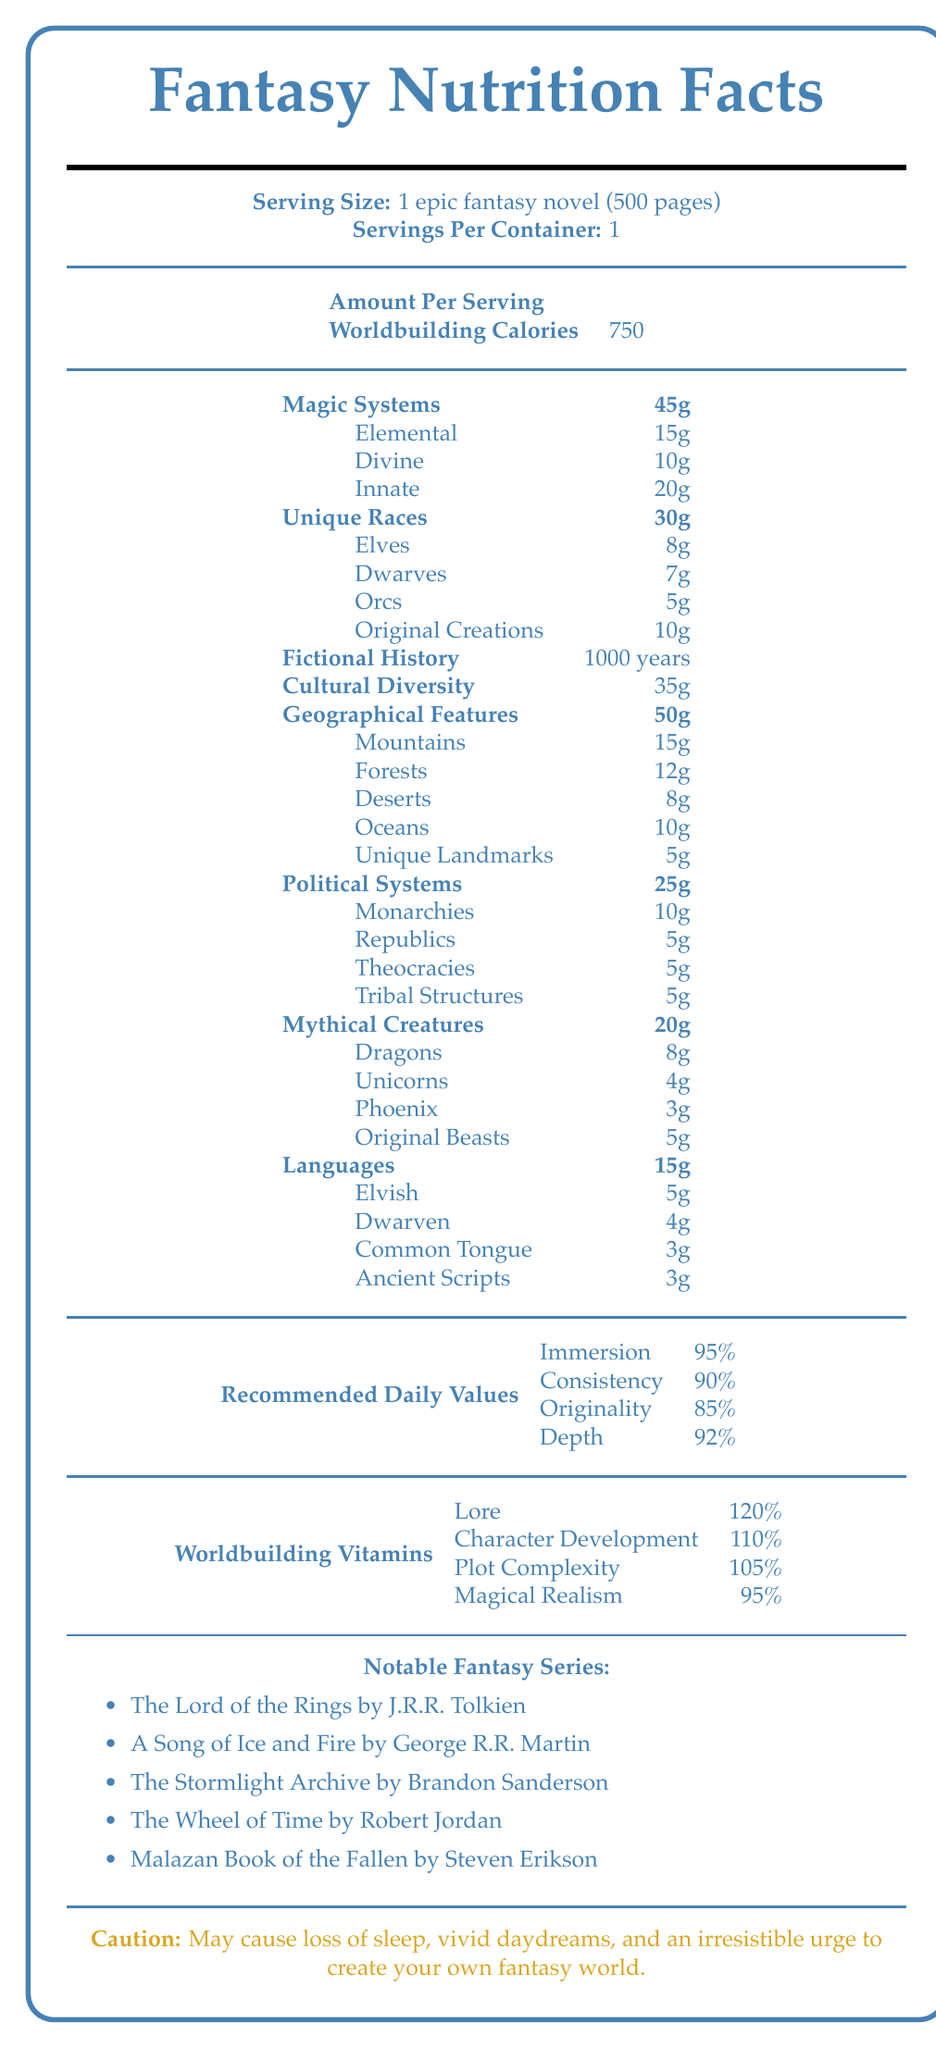1. What is the serving size for this document? The document states that the serving size is 1 epic fantasy novel consisting of 500 pages.
Answer: 1 epic fantasy novel (500 pages) 2. How many calories does the worldbuilding contain per serving? It's listed in the "Amount Per Serving" section as 750 Worldbuilding Calories.
Answer: 750 3. What is the total amount of magic systems in grams per serving? The "Magic Systems" section shows the total as 45g.
Answer: 45g 4. How many grams of Elvish language are there per serving? The "Languages" section indicates that Elvish has 5g per serving.
Answer: 5g 5. Name one fantasy series mentioned in the notable fantasy series list. The list includes "The Lord of the Rings by J.R.R. Tolkien" as one of the notable fantasy series.
Answer: The Lord of the Rings by J.R.R. Tolkien 6. Which type of mythical creature has the highest amount per serving?
   A. Dragons
   B. Unicorns
   C. Phoenix
   D. Original Beasts The "Mythical Creatures" section lists Dragons with the highest amount at 8g.
Answer: A. Dragons 7. What is the percentage of Character Development in Worldbuilding Vitamins?
   I. 95%
   II. 105%
   III. 110%
   IV. 120% The "Worldbuilding Vitamins" section shows Character Development at 110%.
Answer: III. 110% 8. The sum of the grams of Orcs and Elves exceeds the amount of Original Creations. Orcs are 5g and Elves are 8g, totaling 13g. Original Creations are listed as 10g, so the sum (13g) does not exceed 10g.
Answer: No 9. Summarize the main idea of the document. The document is formatted like a nutrition label and breaks down the elements and complexities involved in worldbuilding for an epic fantasy novel. It includes detailed categories, amounts per serving, recommended daily values, and a list of notable fantasy series.
Answer: The document provides a detailed "Nutrition Facts" style breakdown of the components of worldbuilding in an epic fantasy novel, including various elements like magic systems, unique races, fictional history, and more, alongside recommended daily values, vitamins, and notable fantasy series. 10. What is the recommended reading order for the notable fantasy series listed? The document lists notable fantasy series but does not provide a recommended reading order, so this information cannot be determined.
Answer: Not enough information 